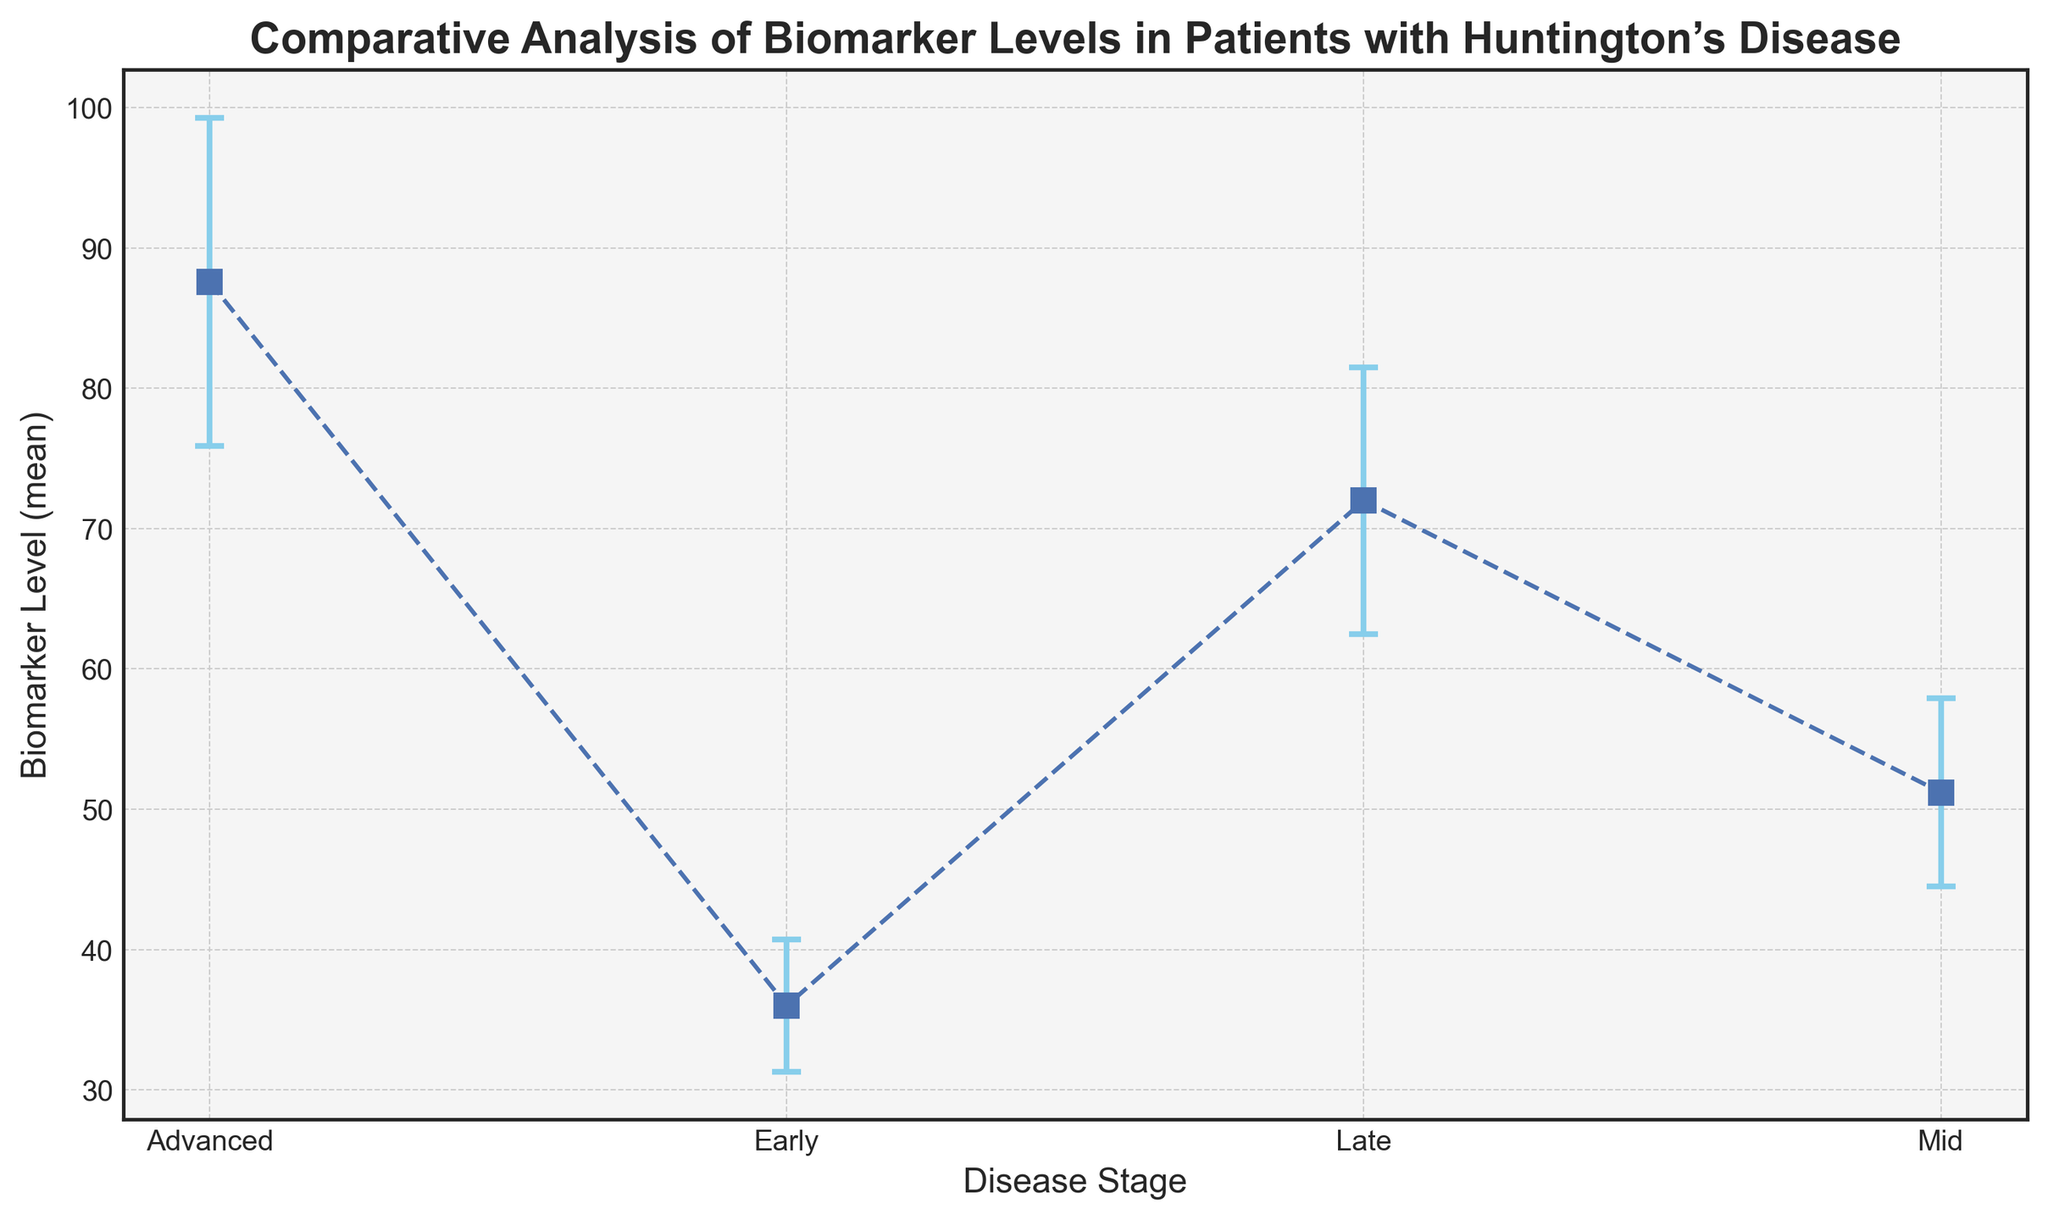What is the average biomarker level for the Early stage? To find the average, first sum the biomarker levels of the Early stage: 35, 38, 36, 37, 34. Then divide by the number of data points: (35 + 38 + 36 + 37 + 34) / 5 = 36
Answer: 36 Which stage has the highest mean biomarker level? To answer this, compare the mean biomarker levels of all the stages: Early (36), Mid (51.2), Late (72), Advanced (87.6). The Advanced stage has the highest mean.
Answer: Advanced By how much does the mean biomarker level increase from the Early to the Late stage? Subtract the mean biomarker level of the Early stage (36) from that of the Late stage (72): 72 - 36 = 36
Answer: 36 Which stage has the largest spread in biomarker levels? The spread is indicated by the standard deviation. Compare the average standard deviations of all the stages: Early (4.7), Mid (6.7), Late (9.54), Advanced (11.1). The Advanced stage has the largest standard deviation.
Answer: Advanced What is the difference in the mean biomarker level between the Mid and Late stages? Find the difference by subtracting the mean biomarker level of the Mid stage (51.2) from that of the Late stage (72): 72 - 51.2 = 20.8
Answer: 20.8 What is the average standard deviation across all stages? First, sum the average standard deviations: 4.7 (Early) + 6.7 (Mid) + 9.54 (Late) + 11.1 (Advanced) = 32.04. Then, divide by the number of stages: 32.04 / 4 = 8.01
Answer: 8.01 Which stage's mean biomarker level is closest to 50? Compare the mean biomarker levels: Early (36), Mid (51.2), Late (72), Advanced (87.6). The Mid stage (51.2) is closest to 50.
Answer: Mid What is the total range of mean biomarker levels observed across all stages? Subtract the lowest mean biomarker level (Early, 36) from the highest mean biomarker level (Advanced, 87.6): 87.6 - 36 = 51.6
Answer: 51.6 What is the combined average biomarker level for the Early and Advanced stages? Sum the mean biomarker levels of Early (36) and Advanced (87.6), and divide by 2: (36 + 87.6) / 2 = 61.8
Answer: 61.8 How much more variable are the biomarker levels in the Late stage compared to the Mid stage? Compare the average standard deviations of Late (9.54) and Mid (6.7). The difference is 9.54 - 6.7 = 2.84
Answer: 2.84 